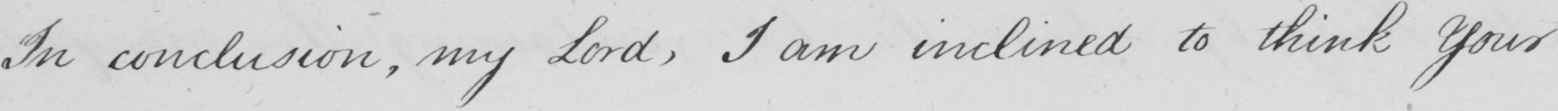Can you tell me what this handwritten text says? In conclusion , my Lord , I am inclined to think Your 